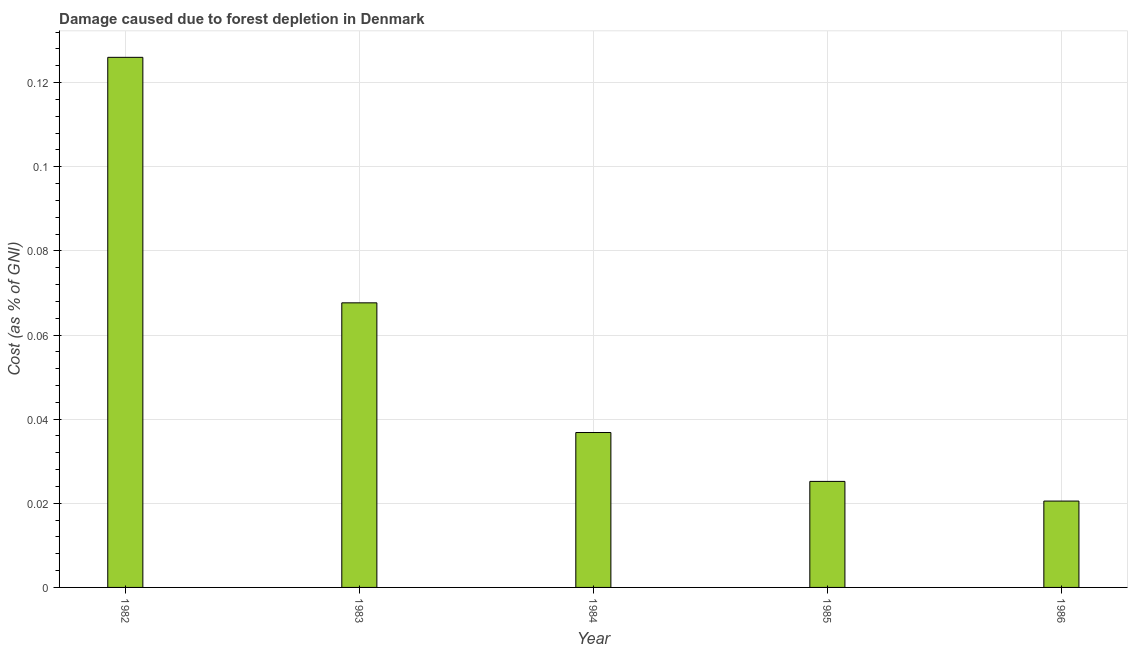What is the title of the graph?
Provide a short and direct response. Damage caused due to forest depletion in Denmark. What is the label or title of the X-axis?
Your response must be concise. Year. What is the label or title of the Y-axis?
Offer a very short reply. Cost (as % of GNI). What is the damage caused due to forest depletion in 1983?
Your answer should be compact. 0.07. Across all years, what is the maximum damage caused due to forest depletion?
Your response must be concise. 0.13. Across all years, what is the minimum damage caused due to forest depletion?
Your response must be concise. 0.02. In which year was the damage caused due to forest depletion maximum?
Ensure brevity in your answer.  1982. In which year was the damage caused due to forest depletion minimum?
Your answer should be very brief. 1986. What is the sum of the damage caused due to forest depletion?
Your response must be concise. 0.28. What is the difference between the damage caused due to forest depletion in 1982 and 1983?
Your answer should be very brief. 0.06. What is the average damage caused due to forest depletion per year?
Ensure brevity in your answer.  0.06. What is the median damage caused due to forest depletion?
Provide a succinct answer. 0.04. What is the ratio of the damage caused due to forest depletion in 1982 to that in 1983?
Provide a short and direct response. 1.86. Is the damage caused due to forest depletion in 1982 less than that in 1984?
Your response must be concise. No. What is the difference between the highest and the second highest damage caused due to forest depletion?
Provide a short and direct response. 0.06. Is the sum of the damage caused due to forest depletion in 1982 and 1984 greater than the maximum damage caused due to forest depletion across all years?
Make the answer very short. Yes. What is the difference between the highest and the lowest damage caused due to forest depletion?
Provide a succinct answer. 0.11. In how many years, is the damage caused due to forest depletion greater than the average damage caused due to forest depletion taken over all years?
Give a very brief answer. 2. How many bars are there?
Make the answer very short. 5. Are all the bars in the graph horizontal?
Your answer should be very brief. No. How many years are there in the graph?
Your answer should be very brief. 5. What is the difference between two consecutive major ticks on the Y-axis?
Provide a succinct answer. 0.02. What is the Cost (as % of GNI) in 1982?
Give a very brief answer. 0.13. What is the Cost (as % of GNI) of 1983?
Offer a very short reply. 0.07. What is the Cost (as % of GNI) in 1984?
Provide a short and direct response. 0.04. What is the Cost (as % of GNI) in 1985?
Ensure brevity in your answer.  0.03. What is the Cost (as % of GNI) in 1986?
Your answer should be very brief. 0.02. What is the difference between the Cost (as % of GNI) in 1982 and 1983?
Your answer should be very brief. 0.06. What is the difference between the Cost (as % of GNI) in 1982 and 1984?
Provide a short and direct response. 0.09. What is the difference between the Cost (as % of GNI) in 1982 and 1985?
Ensure brevity in your answer.  0.1. What is the difference between the Cost (as % of GNI) in 1982 and 1986?
Your answer should be compact. 0.11. What is the difference between the Cost (as % of GNI) in 1983 and 1984?
Your response must be concise. 0.03. What is the difference between the Cost (as % of GNI) in 1983 and 1985?
Your answer should be compact. 0.04. What is the difference between the Cost (as % of GNI) in 1983 and 1986?
Offer a terse response. 0.05. What is the difference between the Cost (as % of GNI) in 1984 and 1985?
Ensure brevity in your answer.  0.01. What is the difference between the Cost (as % of GNI) in 1984 and 1986?
Your response must be concise. 0.02. What is the difference between the Cost (as % of GNI) in 1985 and 1986?
Offer a very short reply. 0. What is the ratio of the Cost (as % of GNI) in 1982 to that in 1983?
Make the answer very short. 1.86. What is the ratio of the Cost (as % of GNI) in 1982 to that in 1984?
Keep it short and to the point. 3.42. What is the ratio of the Cost (as % of GNI) in 1982 to that in 1985?
Your answer should be very brief. 5. What is the ratio of the Cost (as % of GNI) in 1982 to that in 1986?
Your answer should be compact. 6.14. What is the ratio of the Cost (as % of GNI) in 1983 to that in 1984?
Make the answer very short. 1.84. What is the ratio of the Cost (as % of GNI) in 1983 to that in 1985?
Your response must be concise. 2.68. What is the ratio of the Cost (as % of GNI) in 1983 to that in 1986?
Your answer should be very brief. 3.29. What is the ratio of the Cost (as % of GNI) in 1984 to that in 1985?
Provide a short and direct response. 1.46. What is the ratio of the Cost (as % of GNI) in 1984 to that in 1986?
Make the answer very short. 1.79. What is the ratio of the Cost (as % of GNI) in 1985 to that in 1986?
Make the answer very short. 1.23. 